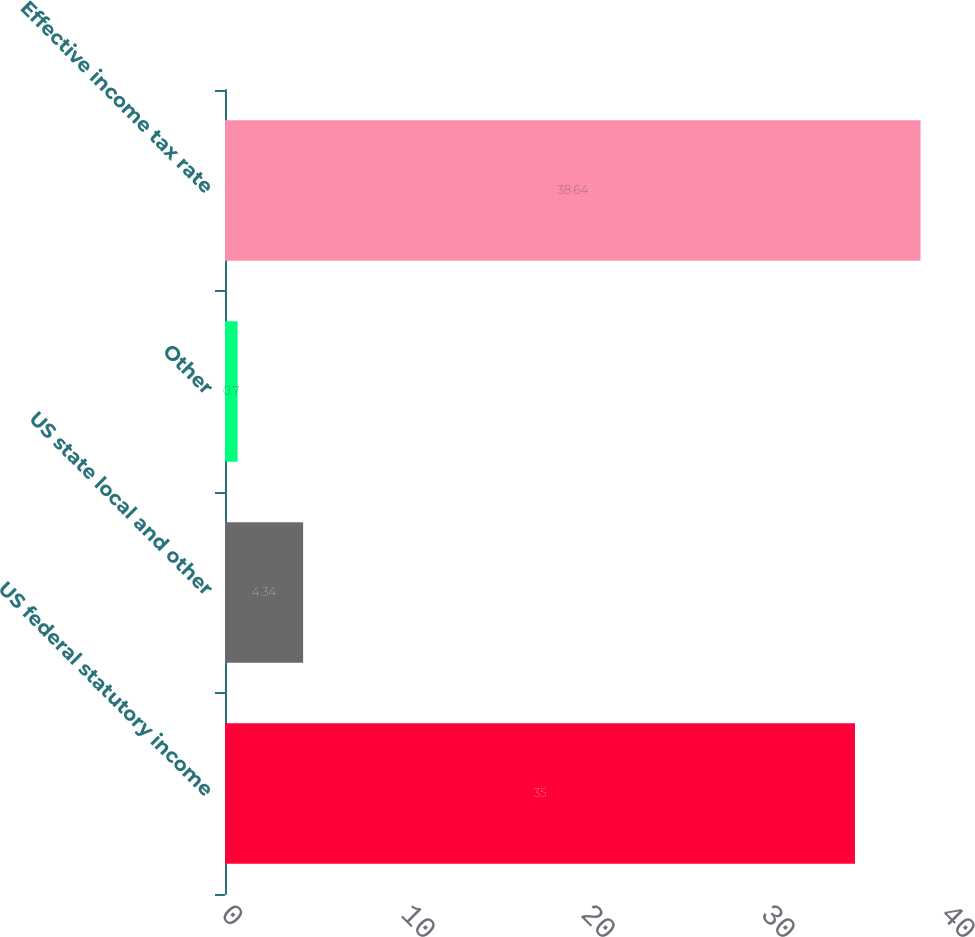Convert chart. <chart><loc_0><loc_0><loc_500><loc_500><bar_chart><fcel>US federal statutory income<fcel>US state local and other<fcel>Other<fcel>Effective income tax rate<nl><fcel>35<fcel>4.34<fcel>0.7<fcel>38.64<nl></chart> 